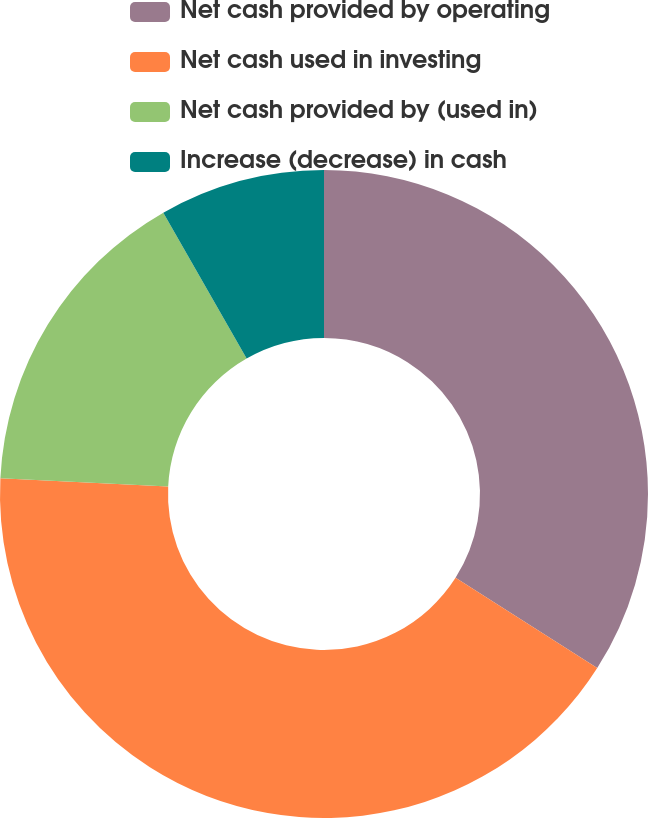Convert chart. <chart><loc_0><loc_0><loc_500><loc_500><pie_chart><fcel>Net cash provided by operating<fcel>Net cash used in investing<fcel>Net cash provided by (used in)<fcel>Increase (decrease) in cash<nl><fcel>34.03%<fcel>41.74%<fcel>15.97%<fcel>8.26%<nl></chart> 